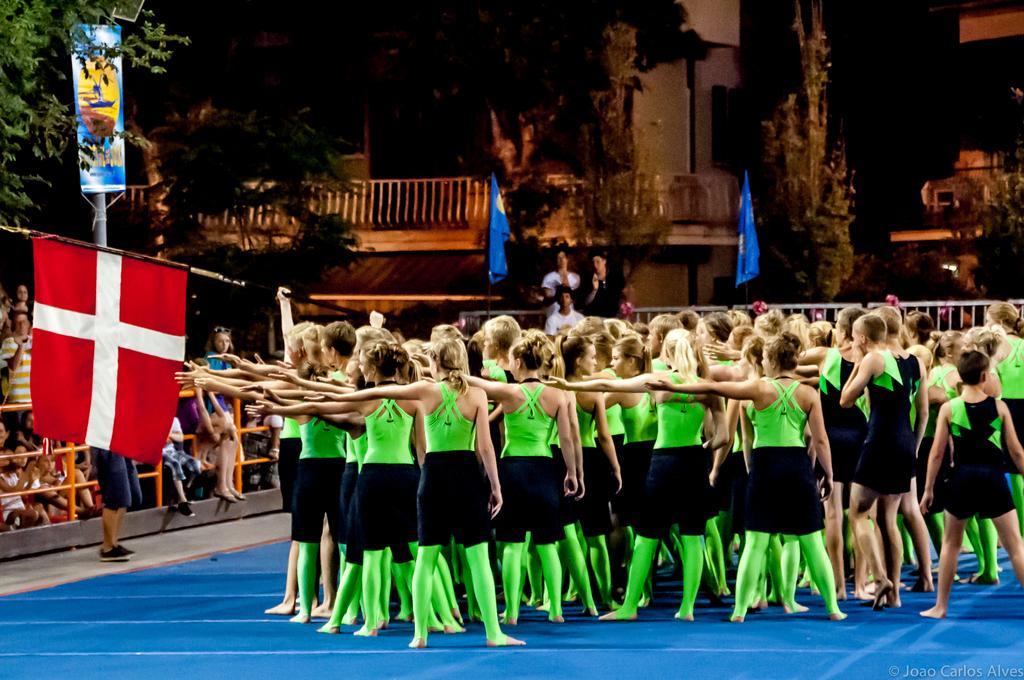In one or two sentences, can you explain what this image depicts? In this image we can see few persons are standing on the carpet and among them a person is holding a flag pole in the hands. On the left side there are few persons at the fence and a hoarding on a pole. In the background there are few persons, buildings, trees and flags. 